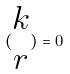<formula> <loc_0><loc_0><loc_500><loc_500>( \begin{matrix} k \\ r \end{matrix} ) = 0</formula> 